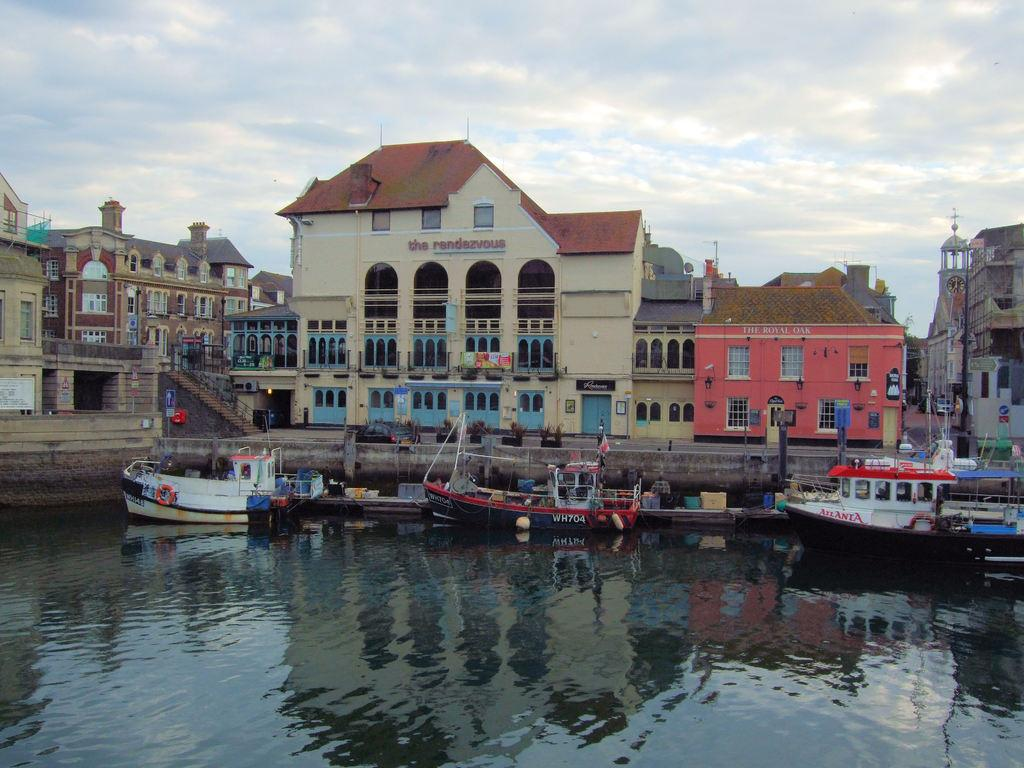<image>
Offer a succinct explanation of the picture presented. The navy and red boat in the middle of the harbour has WH704 written on the side. 